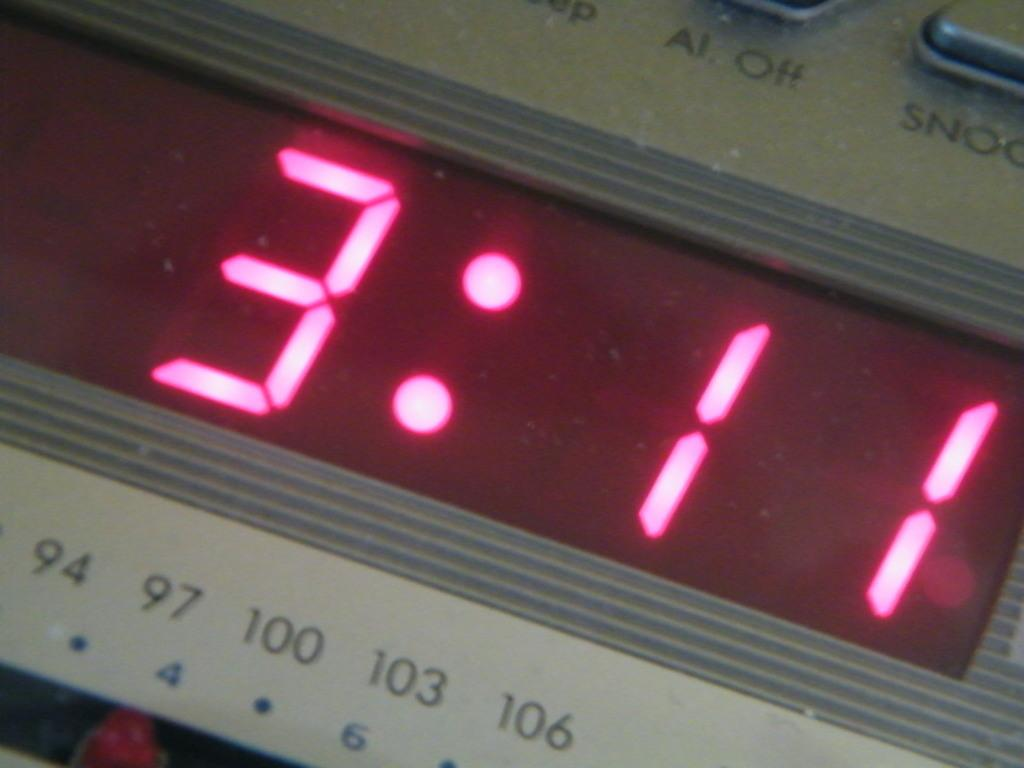<image>
Relay a brief, clear account of the picture shown. a silver digital clock with pick number display reads 3:11 